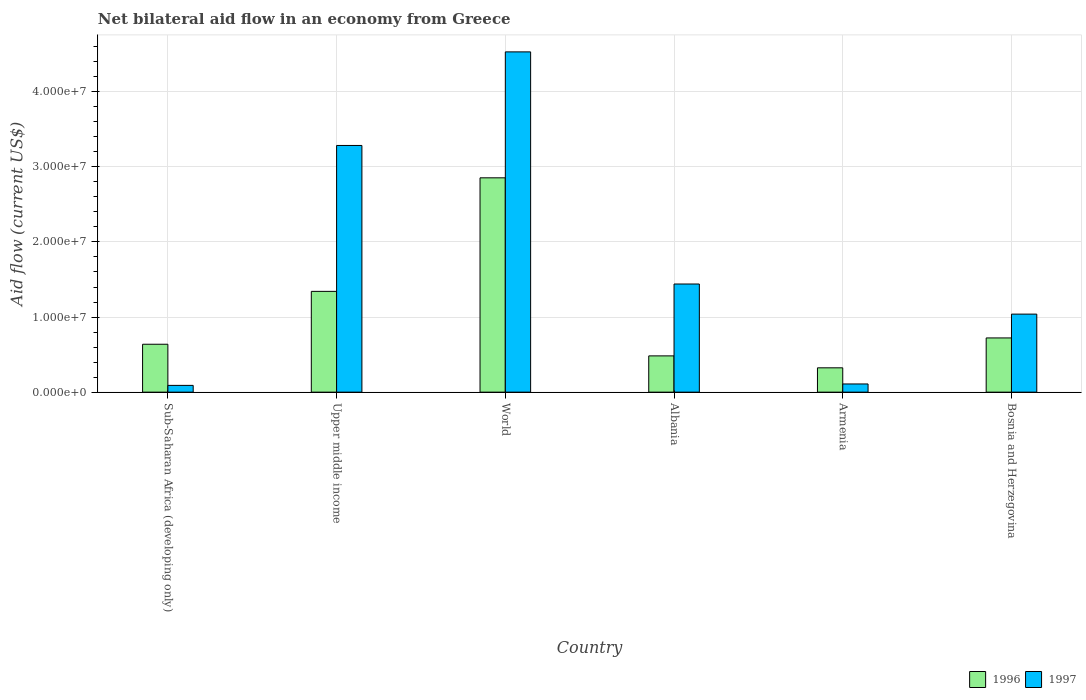How many groups of bars are there?
Keep it short and to the point. 6. Are the number of bars per tick equal to the number of legend labels?
Your answer should be compact. Yes. Are the number of bars on each tick of the X-axis equal?
Offer a very short reply. Yes. How many bars are there on the 1st tick from the right?
Make the answer very short. 2. In how many cases, is the number of bars for a given country not equal to the number of legend labels?
Make the answer very short. 0. What is the net bilateral aid flow in 1997 in Albania?
Your answer should be very brief. 1.44e+07. Across all countries, what is the maximum net bilateral aid flow in 1997?
Keep it short and to the point. 4.53e+07. Across all countries, what is the minimum net bilateral aid flow in 1996?
Give a very brief answer. 3.24e+06. In which country was the net bilateral aid flow in 1997 maximum?
Offer a very short reply. World. In which country was the net bilateral aid flow in 1996 minimum?
Offer a very short reply. Armenia. What is the total net bilateral aid flow in 1996 in the graph?
Offer a terse response. 6.36e+07. What is the difference between the net bilateral aid flow in 1997 in Armenia and that in Bosnia and Herzegovina?
Your answer should be very brief. -9.30e+06. What is the difference between the net bilateral aid flow in 1996 in Upper middle income and the net bilateral aid flow in 1997 in Sub-Saharan Africa (developing only)?
Your answer should be very brief. 1.25e+07. What is the average net bilateral aid flow in 1997 per country?
Offer a terse response. 1.75e+07. What is the difference between the net bilateral aid flow of/in 1996 and net bilateral aid flow of/in 1997 in World?
Ensure brevity in your answer.  -1.68e+07. In how many countries, is the net bilateral aid flow in 1997 greater than 34000000 US$?
Offer a very short reply. 1. What is the ratio of the net bilateral aid flow in 1997 in Albania to that in World?
Your response must be concise. 0.32. What is the difference between the highest and the second highest net bilateral aid flow in 1997?
Make the answer very short. 3.09e+07. What is the difference between the highest and the lowest net bilateral aid flow in 1996?
Provide a succinct answer. 2.53e+07. What does the 1st bar from the left in World represents?
Your answer should be very brief. 1996. What does the 1st bar from the right in Upper middle income represents?
Ensure brevity in your answer.  1997. Are all the bars in the graph horizontal?
Your answer should be very brief. No. Does the graph contain any zero values?
Provide a short and direct response. No. Where does the legend appear in the graph?
Offer a terse response. Bottom right. What is the title of the graph?
Make the answer very short. Net bilateral aid flow in an economy from Greece. What is the label or title of the X-axis?
Your answer should be very brief. Country. What is the Aid flow (current US$) in 1996 in Sub-Saharan Africa (developing only)?
Offer a terse response. 6.38e+06. What is the Aid flow (current US$) of 1996 in Upper middle income?
Ensure brevity in your answer.  1.34e+07. What is the Aid flow (current US$) of 1997 in Upper middle income?
Ensure brevity in your answer.  3.28e+07. What is the Aid flow (current US$) in 1996 in World?
Offer a terse response. 2.85e+07. What is the Aid flow (current US$) in 1997 in World?
Your response must be concise. 4.53e+07. What is the Aid flow (current US$) in 1996 in Albania?
Provide a succinct answer. 4.83e+06. What is the Aid flow (current US$) of 1997 in Albania?
Offer a very short reply. 1.44e+07. What is the Aid flow (current US$) of 1996 in Armenia?
Give a very brief answer. 3.24e+06. What is the Aid flow (current US$) of 1997 in Armenia?
Provide a succinct answer. 1.09e+06. What is the Aid flow (current US$) in 1996 in Bosnia and Herzegovina?
Give a very brief answer. 7.22e+06. What is the Aid flow (current US$) of 1997 in Bosnia and Herzegovina?
Your answer should be compact. 1.04e+07. Across all countries, what is the maximum Aid flow (current US$) in 1996?
Your answer should be compact. 2.85e+07. Across all countries, what is the maximum Aid flow (current US$) of 1997?
Give a very brief answer. 4.53e+07. Across all countries, what is the minimum Aid flow (current US$) in 1996?
Your response must be concise. 3.24e+06. Across all countries, what is the minimum Aid flow (current US$) in 1997?
Provide a succinct answer. 9.00e+05. What is the total Aid flow (current US$) in 1996 in the graph?
Provide a short and direct response. 6.36e+07. What is the total Aid flow (current US$) in 1997 in the graph?
Your answer should be very brief. 1.05e+08. What is the difference between the Aid flow (current US$) in 1996 in Sub-Saharan Africa (developing only) and that in Upper middle income?
Ensure brevity in your answer.  -7.04e+06. What is the difference between the Aid flow (current US$) in 1997 in Sub-Saharan Africa (developing only) and that in Upper middle income?
Your answer should be compact. -3.20e+07. What is the difference between the Aid flow (current US$) in 1996 in Sub-Saharan Africa (developing only) and that in World?
Your response must be concise. -2.22e+07. What is the difference between the Aid flow (current US$) in 1997 in Sub-Saharan Africa (developing only) and that in World?
Ensure brevity in your answer.  -4.44e+07. What is the difference between the Aid flow (current US$) of 1996 in Sub-Saharan Africa (developing only) and that in Albania?
Give a very brief answer. 1.55e+06. What is the difference between the Aid flow (current US$) of 1997 in Sub-Saharan Africa (developing only) and that in Albania?
Offer a very short reply. -1.35e+07. What is the difference between the Aid flow (current US$) of 1996 in Sub-Saharan Africa (developing only) and that in Armenia?
Make the answer very short. 3.14e+06. What is the difference between the Aid flow (current US$) in 1997 in Sub-Saharan Africa (developing only) and that in Armenia?
Offer a very short reply. -1.90e+05. What is the difference between the Aid flow (current US$) of 1996 in Sub-Saharan Africa (developing only) and that in Bosnia and Herzegovina?
Ensure brevity in your answer.  -8.40e+05. What is the difference between the Aid flow (current US$) of 1997 in Sub-Saharan Africa (developing only) and that in Bosnia and Herzegovina?
Offer a very short reply. -9.49e+06. What is the difference between the Aid flow (current US$) in 1996 in Upper middle income and that in World?
Keep it short and to the point. -1.51e+07. What is the difference between the Aid flow (current US$) in 1997 in Upper middle income and that in World?
Offer a very short reply. -1.25e+07. What is the difference between the Aid flow (current US$) in 1996 in Upper middle income and that in Albania?
Give a very brief answer. 8.59e+06. What is the difference between the Aid flow (current US$) of 1997 in Upper middle income and that in Albania?
Your response must be concise. 1.84e+07. What is the difference between the Aid flow (current US$) of 1996 in Upper middle income and that in Armenia?
Make the answer very short. 1.02e+07. What is the difference between the Aid flow (current US$) of 1997 in Upper middle income and that in Armenia?
Your response must be concise. 3.18e+07. What is the difference between the Aid flow (current US$) in 1996 in Upper middle income and that in Bosnia and Herzegovina?
Provide a succinct answer. 6.20e+06. What is the difference between the Aid flow (current US$) in 1997 in Upper middle income and that in Bosnia and Herzegovina?
Give a very brief answer. 2.25e+07. What is the difference between the Aid flow (current US$) in 1996 in World and that in Albania?
Your answer should be compact. 2.37e+07. What is the difference between the Aid flow (current US$) of 1997 in World and that in Albania?
Your answer should be compact. 3.09e+07. What is the difference between the Aid flow (current US$) of 1996 in World and that in Armenia?
Offer a very short reply. 2.53e+07. What is the difference between the Aid flow (current US$) of 1997 in World and that in Armenia?
Your answer should be compact. 4.42e+07. What is the difference between the Aid flow (current US$) of 1996 in World and that in Bosnia and Herzegovina?
Provide a succinct answer. 2.13e+07. What is the difference between the Aid flow (current US$) of 1997 in World and that in Bosnia and Herzegovina?
Make the answer very short. 3.49e+07. What is the difference between the Aid flow (current US$) in 1996 in Albania and that in Armenia?
Provide a succinct answer. 1.59e+06. What is the difference between the Aid flow (current US$) in 1997 in Albania and that in Armenia?
Make the answer very short. 1.33e+07. What is the difference between the Aid flow (current US$) in 1996 in Albania and that in Bosnia and Herzegovina?
Offer a terse response. -2.39e+06. What is the difference between the Aid flow (current US$) in 1997 in Albania and that in Bosnia and Herzegovina?
Your answer should be very brief. 4.01e+06. What is the difference between the Aid flow (current US$) of 1996 in Armenia and that in Bosnia and Herzegovina?
Offer a terse response. -3.98e+06. What is the difference between the Aid flow (current US$) of 1997 in Armenia and that in Bosnia and Herzegovina?
Ensure brevity in your answer.  -9.30e+06. What is the difference between the Aid flow (current US$) of 1996 in Sub-Saharan Africa (developing only) and the Aid flow (current US$) of 1997 in Upper middle income?
Offer a terse response. -2.65e+07. What is the difference between the Aid flow (current US$) of 1996 in Sub-Saharan Africa (developing only) and the Aid flow (current US$) of 1997 in World?
Keep it short and to the point. -3.89e+07. What is the difference between the Aid flow (current US$) of 1996 in Sub-Saharan Africa (developing only) and the Aid flow (current US$) of 1997 in Albania?
Provide a short and direct response. -8.02e+06. What is the difference between the Aid flow (current US$) in 1996 in Sub-Saharan Africa (developing only) and the Aid flow (current US$) in 1997 in Armenia?
Your answer should be very brief. 5.29e+06. What is the difference between the Aid flow (current US$) of 1996 in Sub-Saharan Africa (developing only) and the Aid flow (current US$) of 1997 in Bosnia and Herzegovina?
Your answer should be very brief. -4.01e+06. What is the difference between the Aid flow (current US$) of 1996 in Upper middle income and the Aid flow (current US$) of 1997 in World?
Offer a terse response. -3.19e+07. What is the difference between the Aid flow (current US$) of 1996 in Upper middle income and the Aid flow (current US$) of 1997 in Albania?
Your response must be concise. -9.80e+05. What is the difference between the Aid flow (current US$) of 1996 in Upper middle income and the Aid flow (current US$) of 1997 in Armenia?
Offer a very short reply. 1.23e+07. What is the difference between the Aid flow (current US$) of 1996 in Upper middle income and the Aid flow (current US$) of 1997 in Bosnia and Herzegovina?
Your answer should be compact. 3.03e+06. What is the difference between the Aid flow (current US$) in 1996 in World and the Aid flow (current US$) in 1997 in Albania?
Give a very brief answer. 1.41e+07. What is the difference between the Aid flow (current US$) of 1996 in World and the Aid flow (current US$) of 1997 in Armenia?
Your response must be concise. 2.74e+07. What is the difference between the Aid flow (current US$) in 1996 in World and the Aid flow (current US$) in 1997 in Bosnia and Herzegovina?
Give a very brief answer. 1.82e+07. What is the difference between the Aid flow (current US$) in 1996 in Albania and the Aid flow (current US$) in 1997 in Armenia?
Your response must be concise. 3.74e+06. What is the difference between the Aid flow (current US$) in 1996 in Albania and the Aid flow (current US$) in 1997 in Bosnia and Herzegovina?
Keep it short and to the point. -5.56e+06. What is the difference between the Aid flow (current US$) of 1996 in Armenia and the Aid flow (current US$) of 1997 in Bosnia and Herzegovina?
Your answer should be very brief. -7.15e+06. What is the average Aid flow (current US$) in 1996 per country?
Provide a succinct answer. 1.06e+07. What is the average Aid flow (current US$) in 1997 per country?
Provide a short and direct response. 1.75e+07. What is the difference between the Aid flow (current US$) of 1996 and Aid flow (current US$) of 1997 in Sub-Saharan Africa (developing only)?
Make the answer very short. 5.48e+06. What is the difference between the Aid flow (current US$) of 1996 and Aid flow (current US$) of 1997 in Upper middle income?
Keep it short and to the point. -1.94e+07. What is the difference between the Aid flow (current US$) of 1996 and Aid flow (current US$) of 1997 in World?
Provide a short and direct response. -1.68e+07. What is the difference between the Aid flow (current US$) in 1996 and Aid flow (current US$) in 1997 in Albania?
Provide a succinct answer. -9.57e+06. What is the difference between the Aid flow (current US$) in 1996 and Aid flow (current US$) in 1997 in Armenia?
Your response must be concise. 2.15e+06. What is the difference between the Aid flow (current US$) in 1996 and Aid flow (current US$) in 1997 in Bosnia and Herzegovina?
Make the answer very short. -3.17e+06. What is the ratio of the Aid flow (current US$) of 1996 in Sub-Saharan Africa (developing only) to that in Upper middle income?
Provide a succinct answer. 0.48. What is the ratio of the Aid flow (current US$) of 1997 in Sub-Saharan Africa (developing only) to that in Upper middle income?
Your response must be concise. 0.03. What is the ratio of the Aid flow (current US$) of 1996 in Sub-Saharan Africa (developing only) to that in World?
Ensure brevity in your answer.  0.22. What is the ratio of the Aid flow (current US$) of 1997 in Sub-Saharan Africa (developing only) to that in World?
Your answer should be compact. 0.02. What is the ratio of the Aid flow (current US$) in 1996 in Sub-Saharan Africa (developing only) to that in Albania?
Ensure brevity in your answer.  1.32. What is the ratio of the Aid flow (current US$) in 1997 in Sub-Saharan Africa (developing only) to that in Albania?
Offer a very short reply. 0.06. What is the ratio of the Aid flow (current US$) in 1996 in Sub-Saharan Africa (developing only) to that in Armenia?
Keep it short and to the point. 1.97. What is the ratio of the Aid flow (current US$) of 1997 in Sub-Saharan Africa (developing only) to that in Armenia?
Your answer should be compact. 0.83. What is the ratio of the Aid flow (current US$) in 1996 in Sub-Saharan Africa (developing only) to that in Bosnia and Herzegovina?
Your response must be concise. 0.88. What is the ratio of the Aid flow (current US$) in 1997 in Sub-Saharan Africa (developing only) to that in Bosnia and Herzegovina?
Give a very brief answer. 0.09. What is the ratio of the Aid flow (current US$) in 1996 in Upper middle income to that in World?
Make the answer very short. 0.47. What is the ratio of the Aid flow (current US$) of 1997 in Upper middle income to that in World?
Your answer should be compact. 0.72. What is the ratio of the Aid flow (current US$) in 1996 in Upper middle income to that in Albania?
Make the answer very short. 2.78. What is the ratio of the Aid flow (current US$) of 1997 in Upper middle income to that in Albania?
Your answer should be compact. 2.28. What is the ratio of the Aid flow (current US$) in 1996 in Upper middle income to that in Armenia?
Offer a terse response. 4.14. What is the ratio of the Aid flow (current US$) of 1997 in Upper middle income to that in Armenia?
Ensure brevity in your answer.  30.14. What is the ratio of the Aid flow (current US$) in 1996 in Upper middle income to that in Bosnia and Herzegovina?
Provide a succinct answer. 1.86. What is the ratio of the Aid flow (current US$) of 1997 in Upper middle income to that in Bosnia and Herzegovina?
Offer a terse response. 3.16. What is the ratio of the Aid flow (current US$) in 1996 in World to that in Albania?
Provide a succinct answer. 5.91. What is the ratio of the Aid flow (current US$) of 1997 in World to that in Albania?
Keep it short and to the point. 3.15. What is the ratio of the Aid flow (current US$) of 1996 in World to that in Armenia?
Provide a succinct answer. 8.81. What is the ratio of the Aid flow (current US$) in 1997 in World to that in Armenia?
Your answer should be compact. 41.57. What is the ratio of the Aid flow (current US$) of 1996 in World to that in Bosnia and Herzegovina?
Your answer should be very brief. 3.95. What is the ratio of the Aid flow (current US$) in 1997 in World to that in Bosnia and Herzegovina?
Give a very brief answer. 4.36. What is the ratio of the Aid flow (current US$) of 1996 in Albania to that in Armenia?
Provide a succinct answer. 1.49. What is the ratio of the Aid flow (current US$) in 1997 in Albania to that in Armenia?
Give a very brief answer. 13.21. What is the ratio of the Aid flow (current US$) in 1996 in Albania to that in Bosnia and Herzegovina?
Provide a succinct answer. 0.67. What is the ratio of the Aid flow (current US$) in 1997 in Albania to that in Bosnia and Herzegovina?
Offer a terse response. 1.39. What is the ratio of the Aid flow (current US$) in 1996 in Armenia to that in Bosnia and Herzegovina?
Provide a short and direct response. 0.45. What is the ratio of the Aid flow (current US$) of 1997 in Armenia to that in Bosnia and Herzegovina?
Your answer should be very brief. 0.1. What is the difference between the highest and the second highest Aid flow (current US$) in 1996?
Give a very brief answer. 1.51e+07. What is the difference between the highest and the second highest Aid flow (current US$) of 1997?
Offer a terse response. 1.25e+07. What is the difference between the highest and the lowest Aid flow (current US$) of 1996?
Make the answer very short. 2.53e+07. What is the difference between the highest and the lowest Aid flow (current US$) in 1997?
Provide a succinct answer. 4.44e+07. 